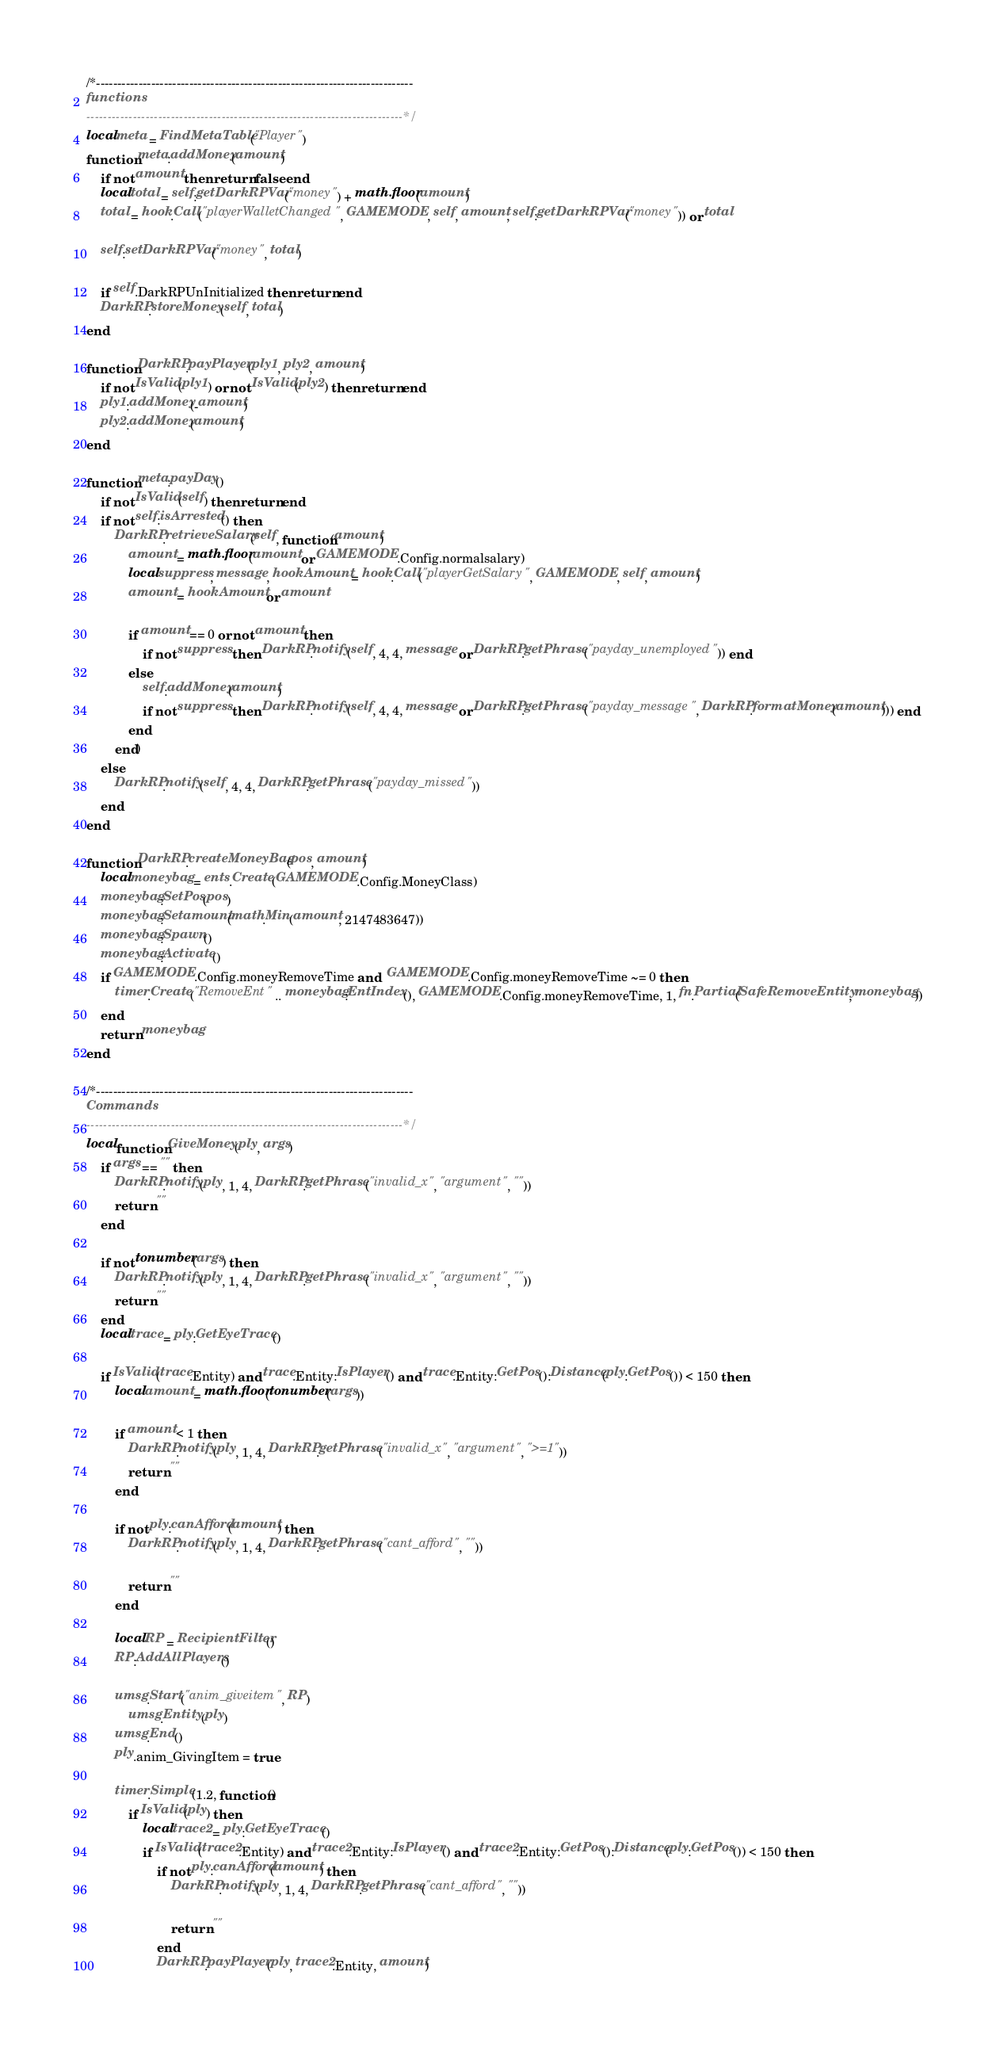<code> <loc_0><loc_0><loc_500><loc_500><_Lua_>/*---------------------------------------------------------------------------
functions
---------------------------------------------------------------------------*/
local meta = FindMetaTable("Player")
function meta:addMoney(amount)
    if not amount then return false end
    local total = self:getDarkRPVar("money") + math.floor(amount)
    total = hook.Call("playerWalletChanged", GAMEMODE, self, amount, self:getDarkRPVar("money")) or total

    self:setDarkRPVar("money", total)

    if self.DarkRPUnInitialized then return end
    DarkRP.storeMoney(self, total)
end

function DarkRP.payPlayer(ply1, ply2, amount)
    if not IsValid(ply1) or not IsValid(ply2) then return end
    ply1:addMoney(-amount)
    ply2:addMoney(amount)
end

function meta:payDay()
    if not IsValid(self) then return end
    if not self:isArrested() then
        DarkRP.retrieveSalary(self, function(amount)
            amount = math.floor(amount or GAMEMODE.Config.normalsalary)
            local suppress, message, hookAmount = hook.Call("playerGetSalary", GAMEMODE, self, amount)
            amount = hookAmount or amount

            if amount == 0 or not amount then
                if not suppress then DarkRP.notify(self, 4, 4, message or DarkRP.getPhrase("payday_unemployed")) end
            else
                self:addMoney(amount)
                if not suppress then DarkRP.notify(self, 4, 4, message or DarkRP.getPhrase("payday_message", DarkRP.formatMoney(amount))) end
            end
        end)
    else
        DarkRP.notify(self, 4, 4, DarkRP.getPhrase("payday_missed"))
    end
end

function DarkRP.createMoneyBag(pos, amount)
    local moneybag = ents.Create(GAMEMODE.Config.MoneyClass)
    moneybag:SetPos(pos)
    moneybag:Setamount(math.Min(amount, 2147483647))
    moneybag:Spawn()
    moneybag:Activate()
    if GAMEMODE.Config.moneyRemoveTime and  GAMEMODE.Config.moneyRemoveTime ~= 0 then
        timer.Create("RemoveEnt" .. moneybag:EntIndex(), GAMEMODE.Config.moneyRemoveTime, 1, fn.Partial(SafeRemoveEntity, moneybag))
    end
    return moneybag
end

/*---------------------------------------------------------------------------
Commands
---------------------------------------------------------------------------*/
local function GiveMoney(ply, args)
    if args == "" then
        DarkRP.notify(ply, 1, 4, DarkRP.getPhrase("invalid_x", "argument", ""))
        return ""
    end

    if not tonumber(args) then
        DarkRP.notify(ply, 1, 4, DarkRP.getPhrase("invalid_x", "argument", ""))
        return ""
    end
    local trace = ply:GetEyeTrace()

    if IsValid(trace.Entity) and trace.Entity:IsPlayer() and trace.Entity:GetPos():Distance(ply:GetPos()) < 150 then
        local amount = math.floor(tonumber(args))

        if amount < 1 then
            DarkRP.notify(ply, 1, 4, DarkRP.getPhrase("invalid_x", "argument", ">=1"))
            return ""
        end

        if not ply:canAfford(amount) then
            DarkRP.notify(ply, 1, 4, DarkRP.getPhrase("cant_afford", ""))

            return ""
        end

        local RP = RecipientFilter()
        RP:AddAllPlayers()

        umsg.Start("anim_giveitem", RP)
            umsg.Entity(ply)
        umsg.End()
        ply.anim_GivingItem = true

        timer.Simple(1.2, function()
            if IsValid(ply) then
                local trace2 = ply:GetEyeTrace()
                if IsValid(trace2.Entity) and trace2.Entity:IsPlayer() and trace2.Entity:GetPos():Distance(ply:GetPos()) < 150 then
                    if not ply:canAfford(amount) then
                        DarkRP.notify(ply, 1, 4, DarkRP.getPhrase("cant_afford", ""))

                        return ""
                    end
                    DarkRP.payPlayer(ply, trace2.Entity, amount)
</code> 